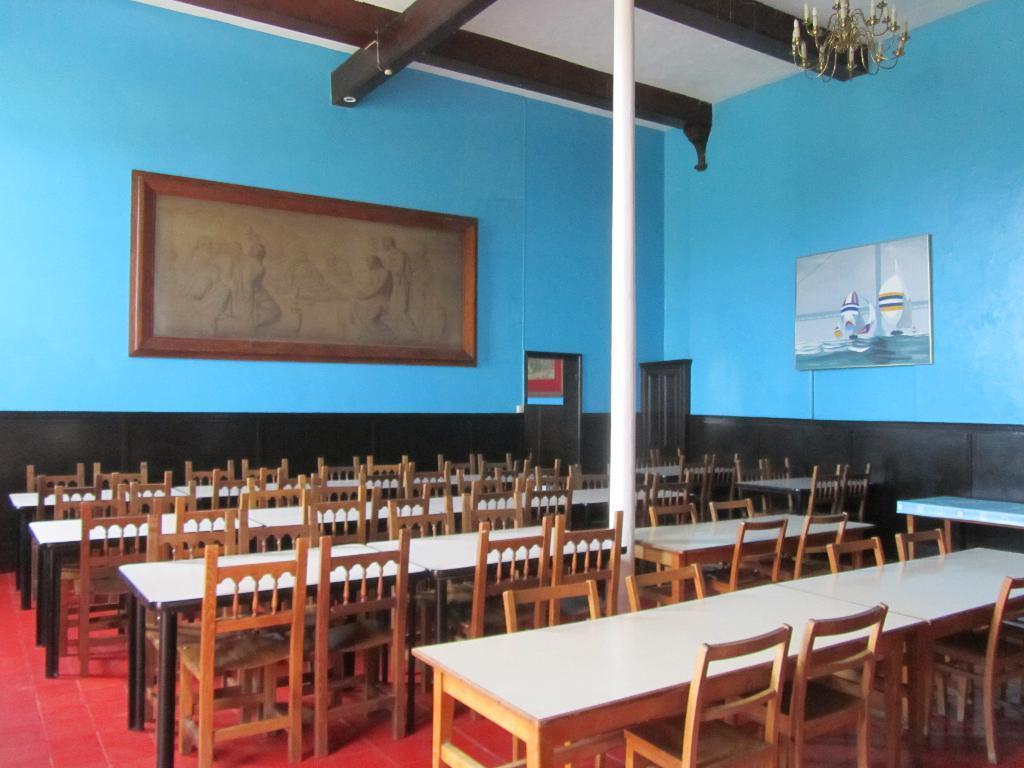Can you describe this image briefly? This is an inside picture of the room, there are some chairs, tables and photo frames on the wall, at the top we can see the chandelier and also we can see a pole. 